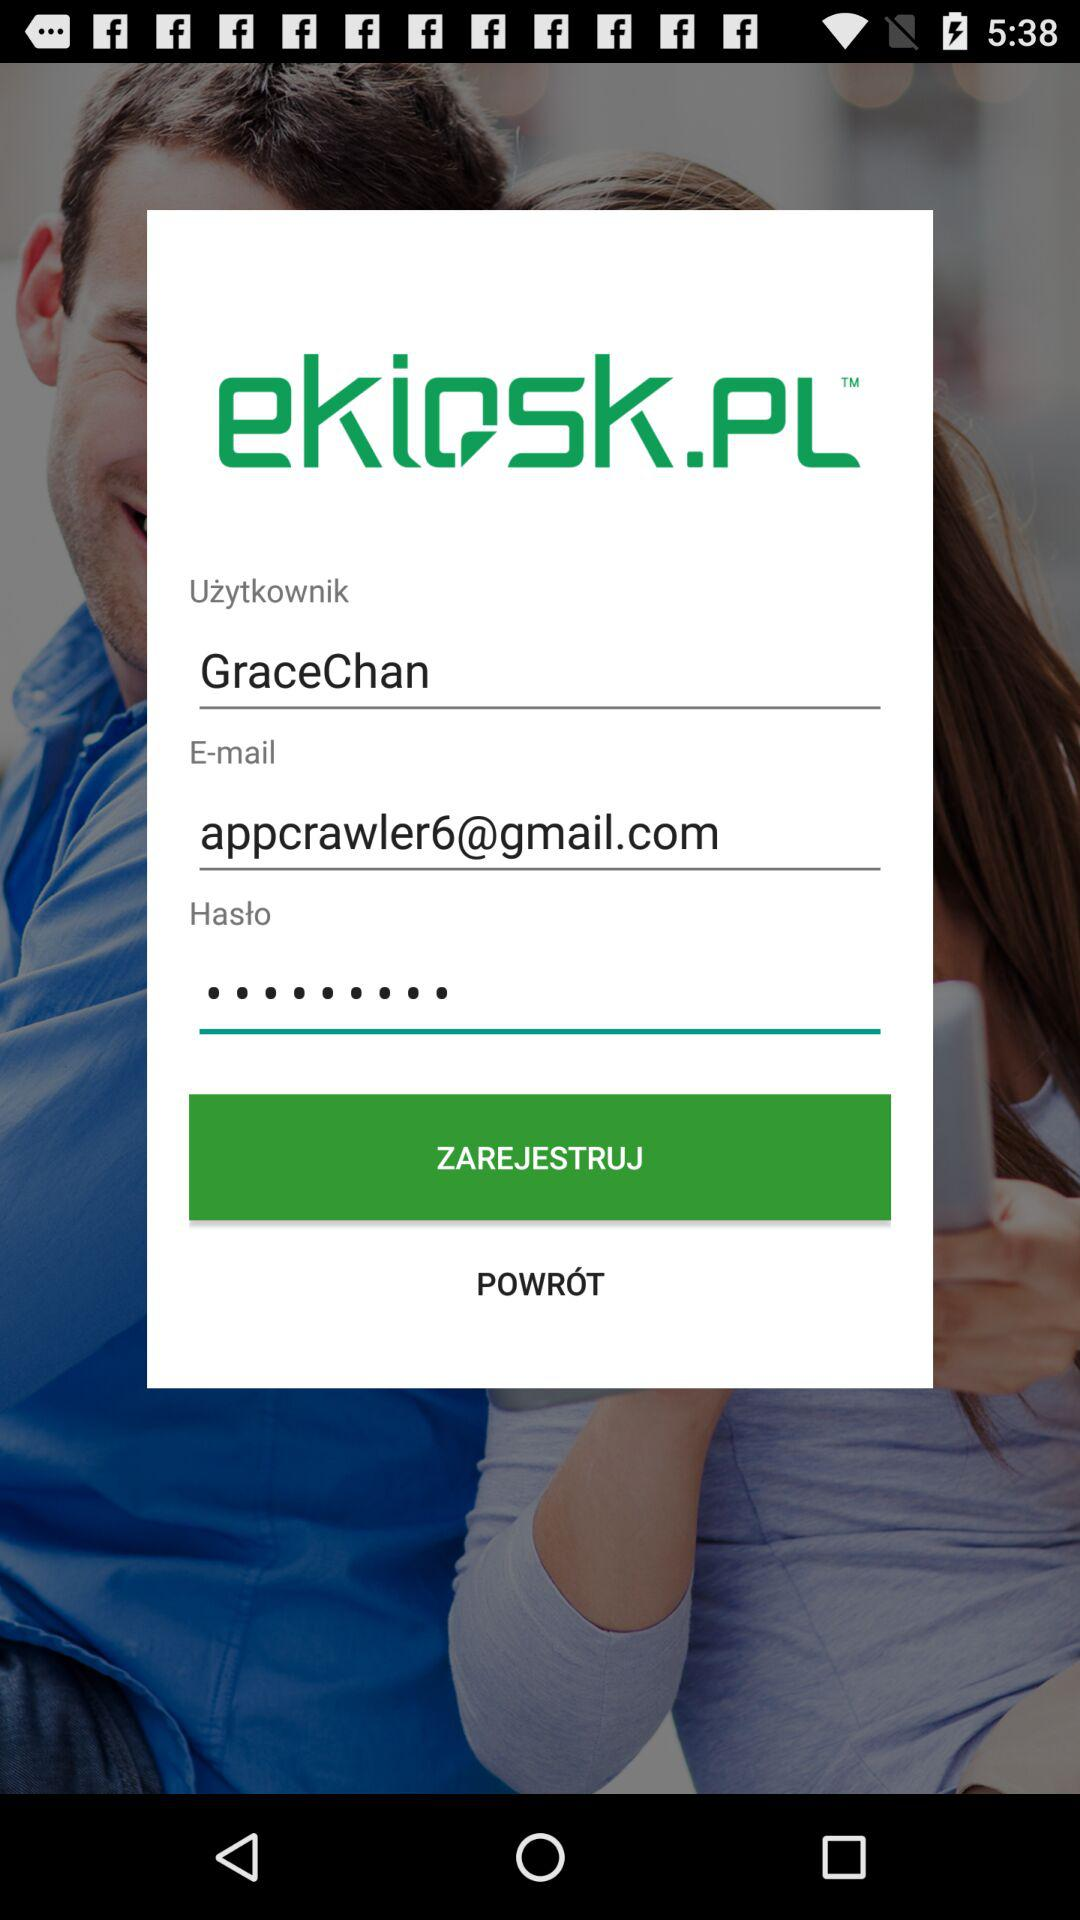How many text inputs are on the screen?
Answer the question using a single word or phrase. 3 